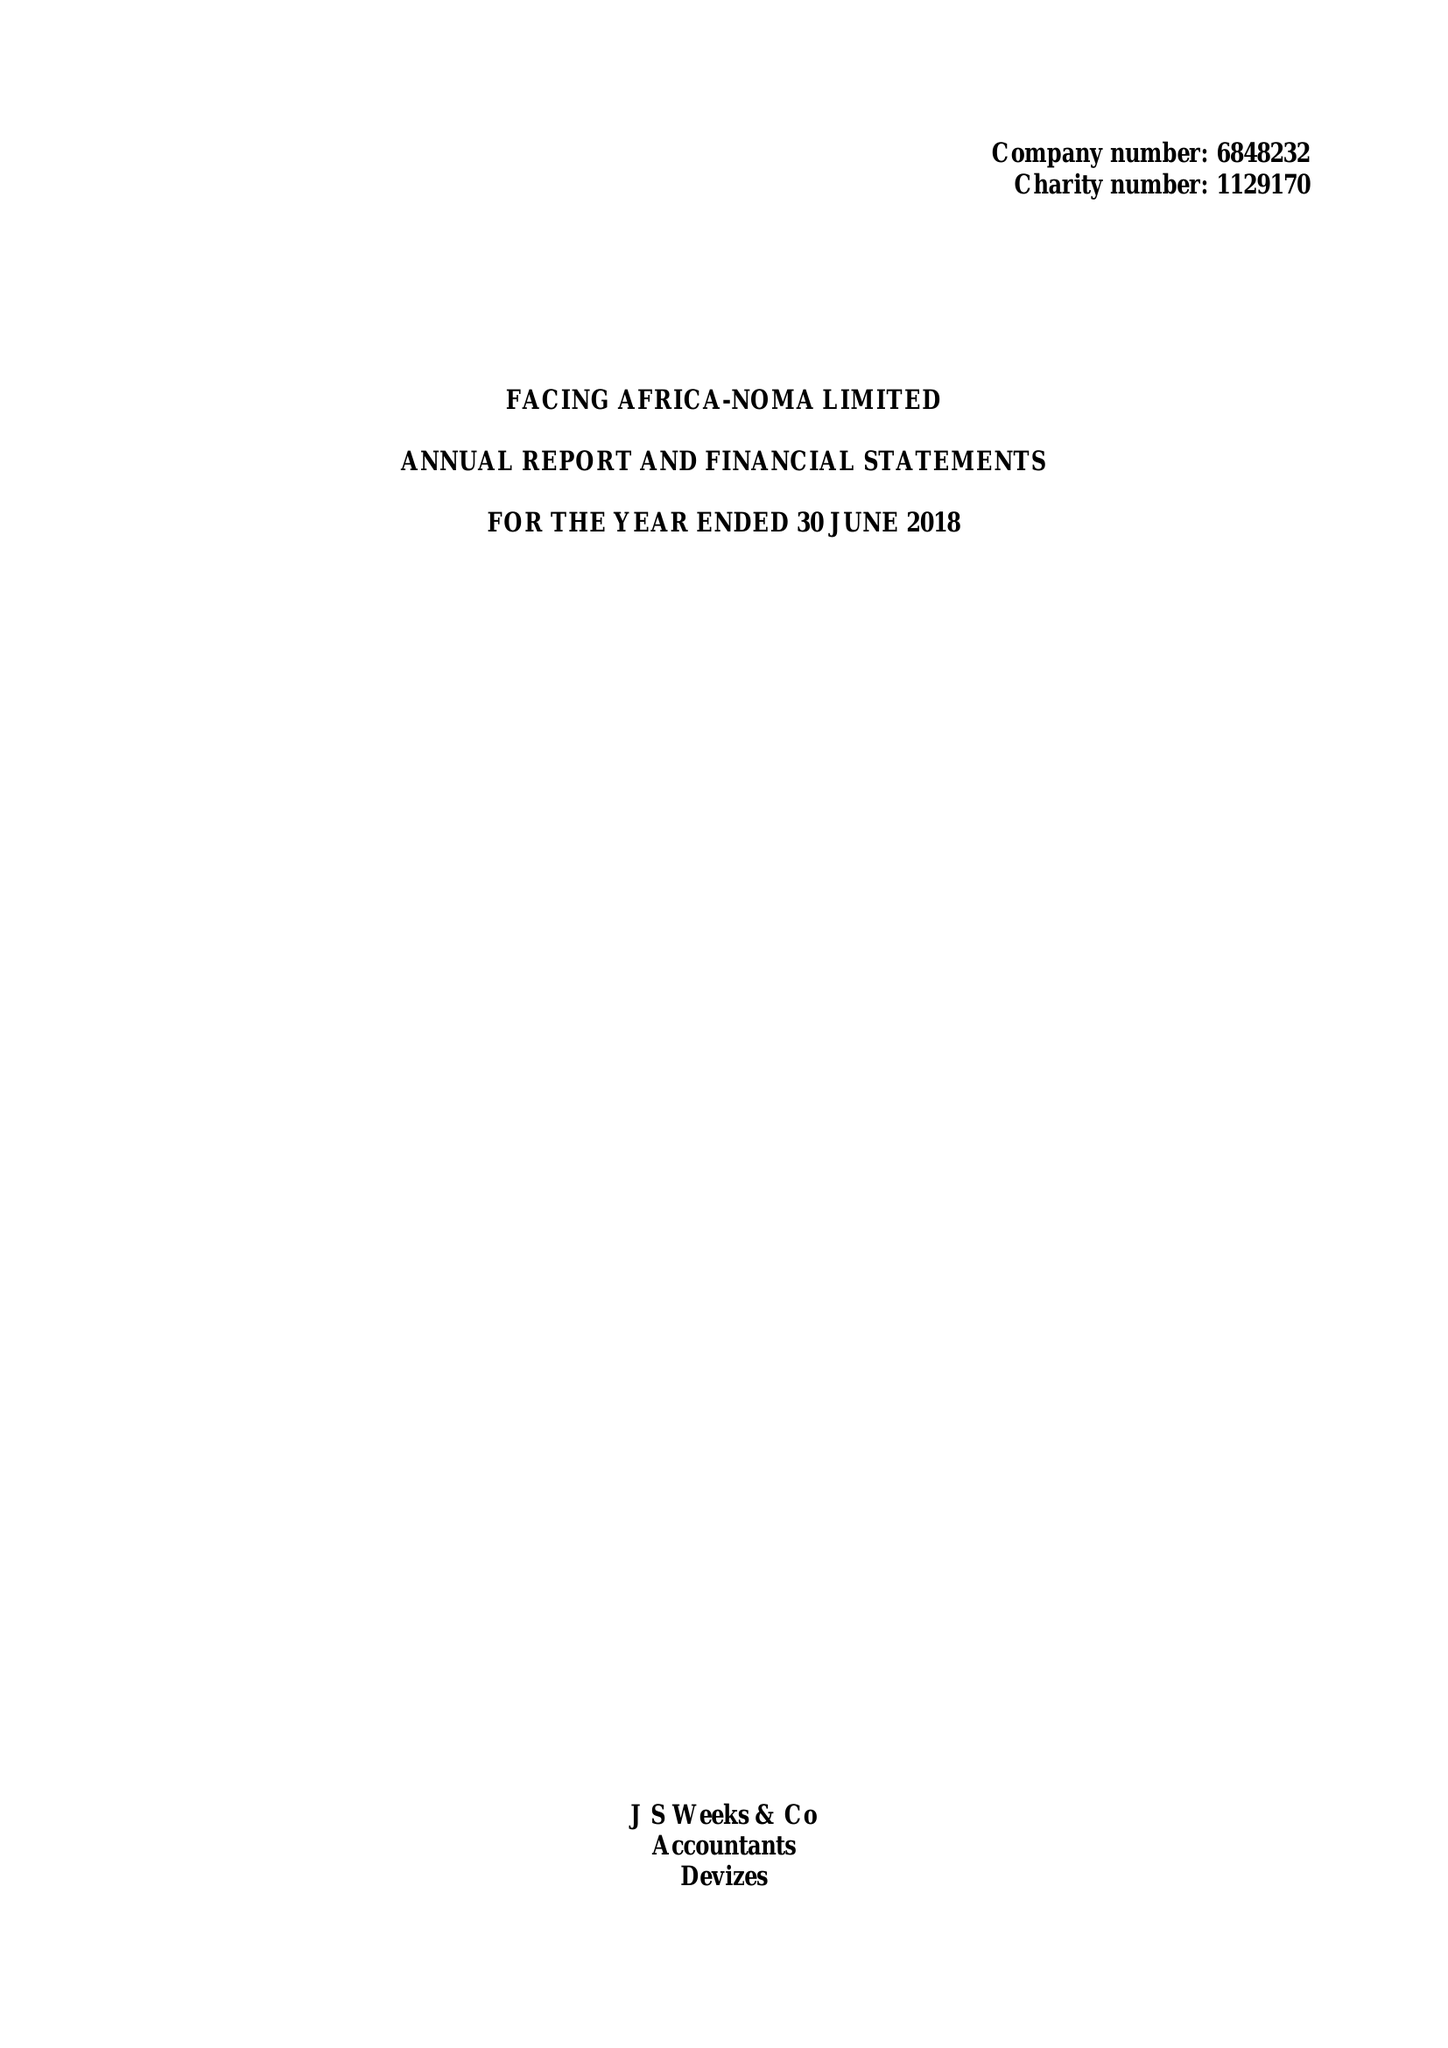What is the value for the income_annually_in_british_pounds?
Answer the question using a single word or phrase. 176507.00 